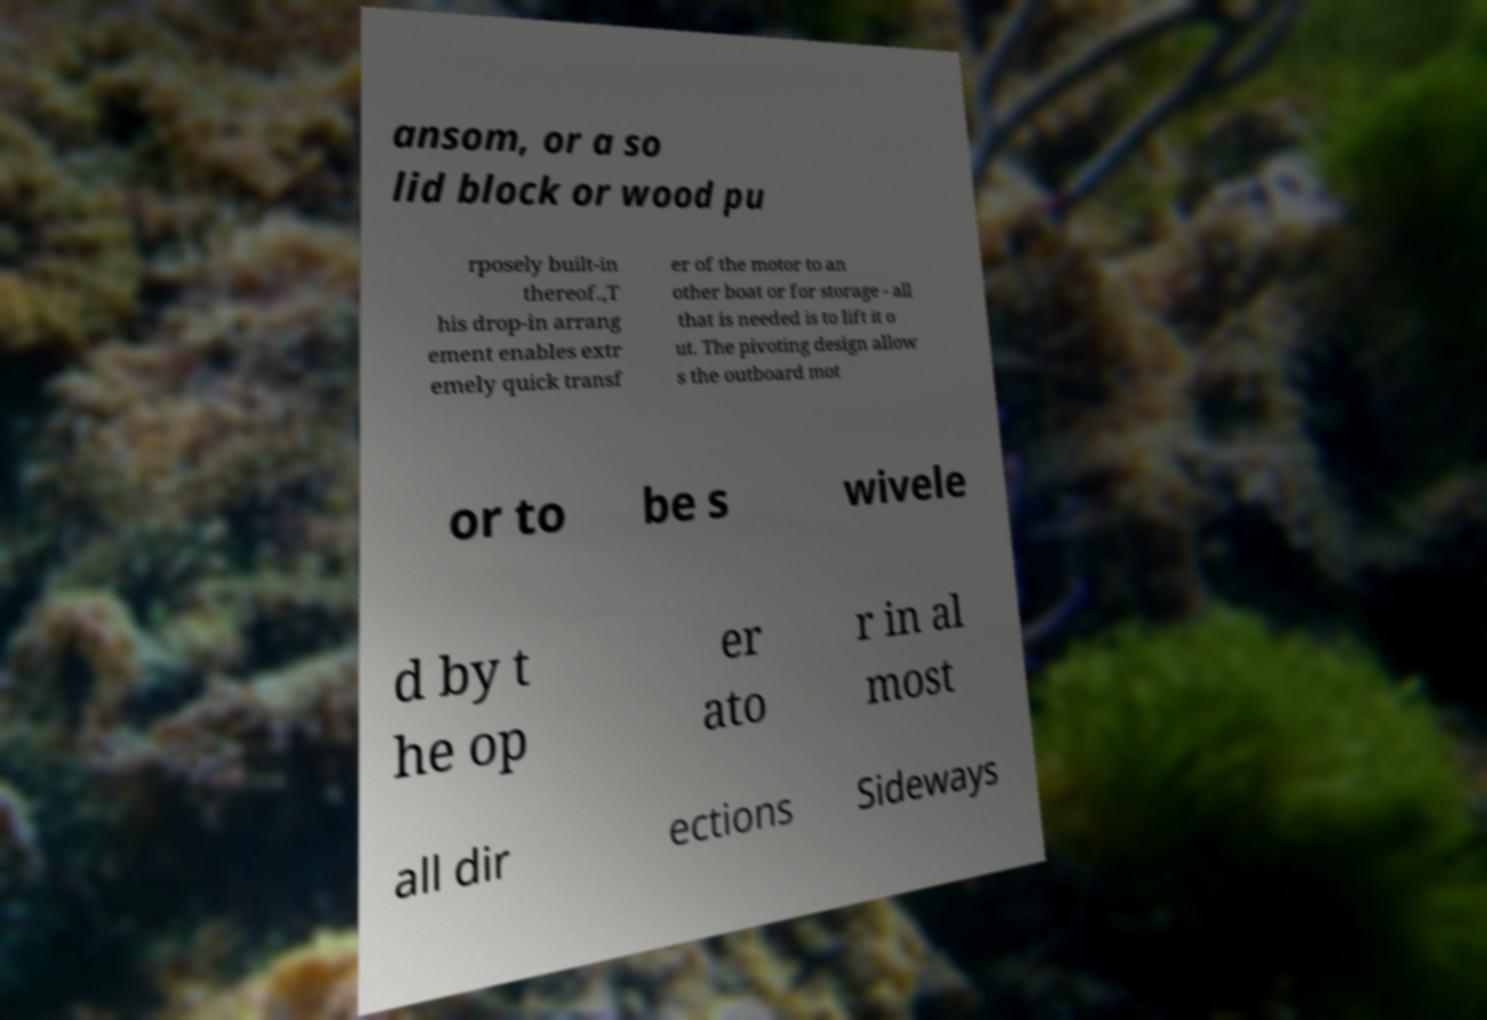Can you read and provide the text displayed in the image?This photo seems to have some interesting text. Can you extract and type it out for me? ansom, or a so lid block or wood pu rposely built-in thereof.,T his drop-in arrang ement enables extr emely quick transf er of the motor to an other boat or for storage - all that is needed is to lift it o ut. The pivoting design allow s the outboard mot or to be s wivele d by t he op er ato r in al most all dir ections Sideways 